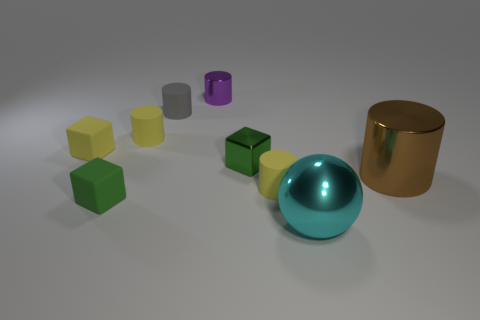Is the number of rubber cylinders that are on the right side of the green matte cube greater than the number of small metal blocks?
Your response must be concise. Yes. What is the color of the large metallic ball?
Give a very brief answer. Cyan. There is a big shiny object that is in front of the big object that is on the right side of the cyan shiny object on the left side of the big brown cylinder; what shape is it?
Provide a short and direct response. Sphere. What material is the cylinder that is both left of the cyan shiny sphere and on the right side of the green metal thing?
Provide a succinct answer. Rubber. What shape is the cyan object in front of the gray rubber object behind the small green matte cube?
Offer a very short reply. Sphere. Is there any other thing that has the same color as the small metallic cylinder?
Your response must be concise. No. There is a brown object; does it have the same size as the block that is right of the purple metallic cylinder?
Your response must be concise. No. What number of tiny objects are green things or brown metal objects?
Give a very brief answer. 2. Are there more big brown cylinders than gray metallic things?
Offer a very short reply. Yes. What number of big cyan things are behind the green block behind the small matte cylinder to the right of the small gray cylinder?
Offer a terse response. 0. 